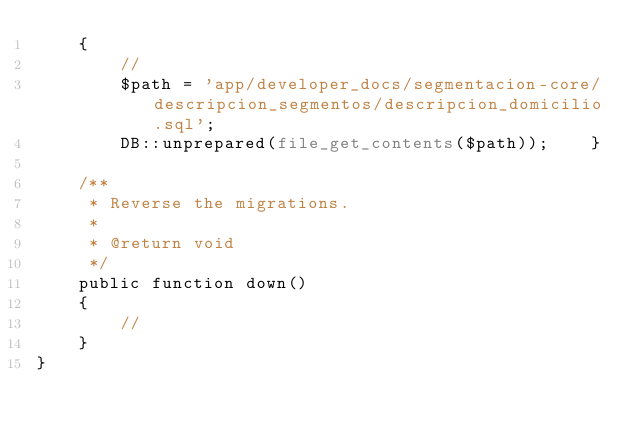Convert code to text. <code><loc_0><loc_0><loc_500><loc_500><_PHP_>    {
        //
        $path = 'app/developer_docs/segmentacion-core/descripcion_segmentos/descripcion_domicilio.sql';
        DB::unprepared(file_get_contents($path));    }

    /**
     * Reverse the migrations.
     *
     * @return void
     */
    public function down()
    {
        //
    }
}
</code> 